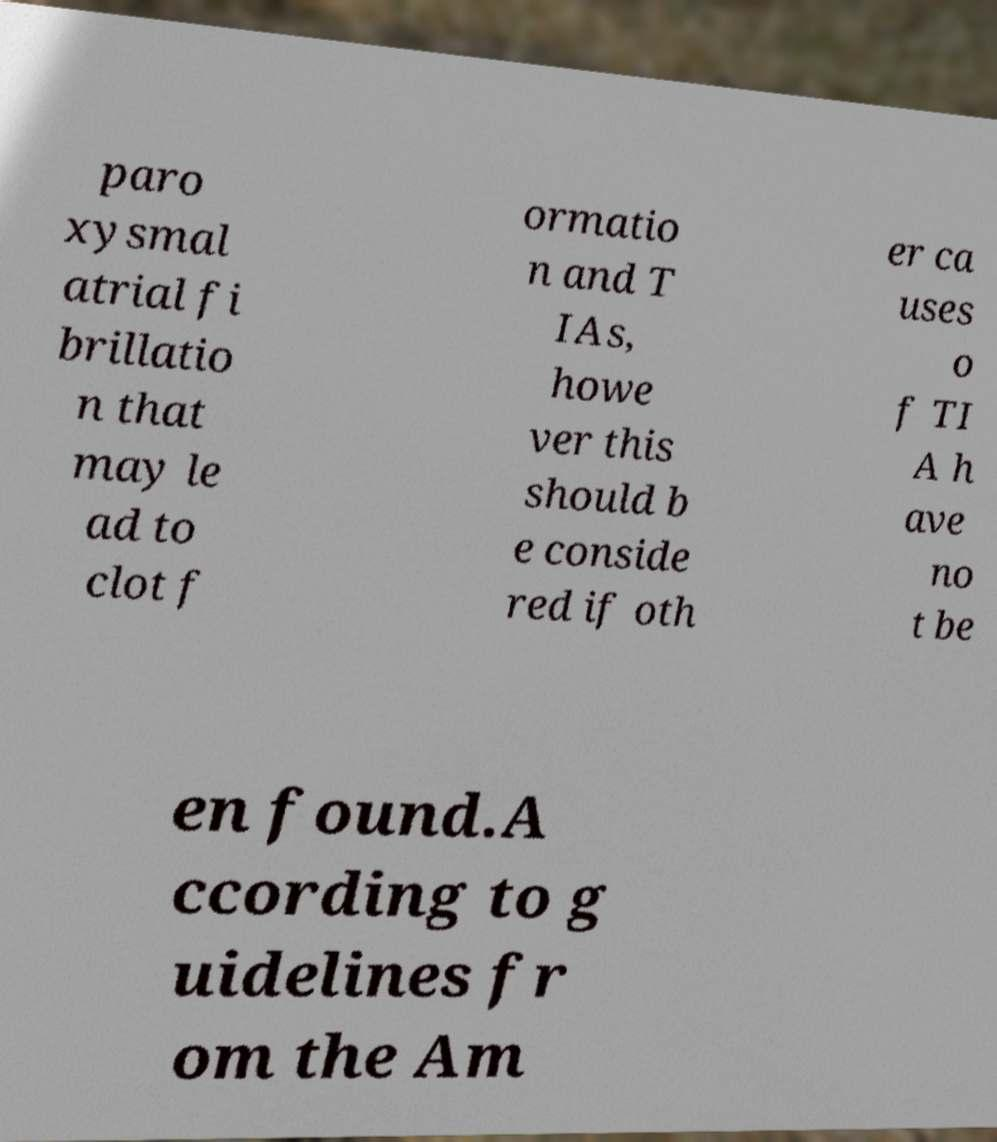Please identify and transcribe the text found in this image. paro xysmal atrial fi brillatio n that may le ad to clot f ormatio n and T IAs, howe ver this should b e conside red if oth er ca uses o f TI A h ave no t be en found.A ccording to g uidelines fr om the Am 